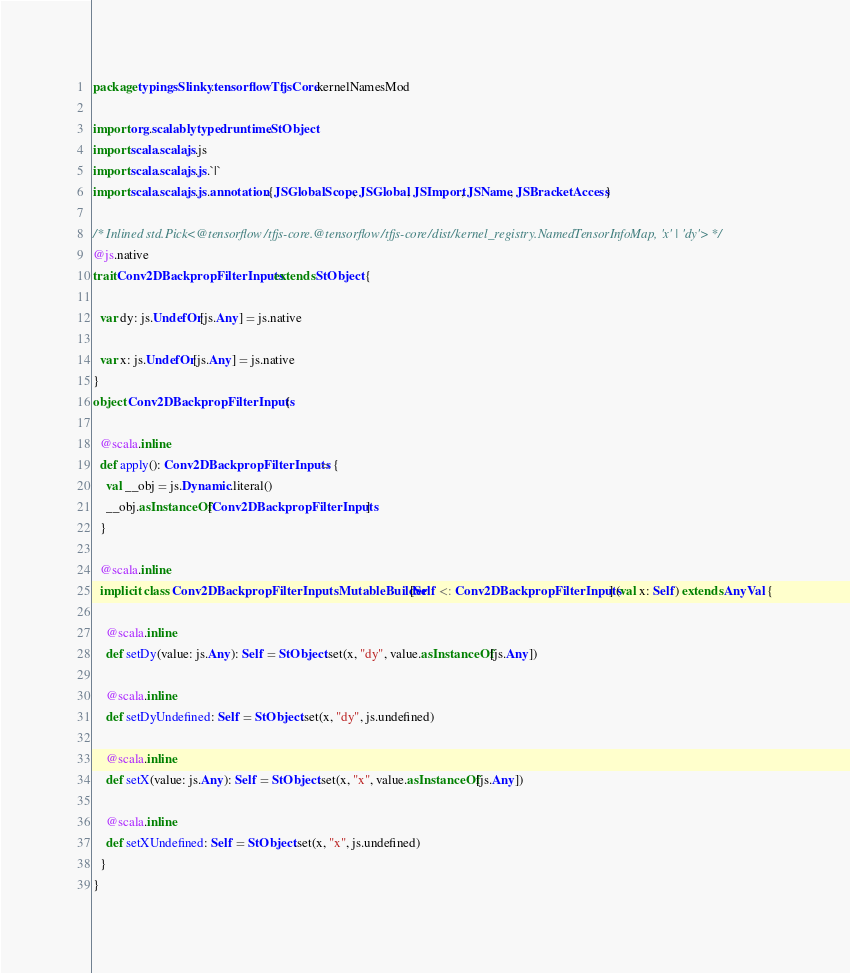<code> <loc_0><loc_0><loc_500><loc_500><_Scala_>package typingsSlinky.tensorflowTfjsCore.kernelNamesMod

import org.scalablytyped.runtime.StObject
import scala.scalajs.js
import scala.scalajs.js.`|`
import scala.scalajs.js.annotation.{JSGlobalScope, JSGlobal, JSImport, JSName, JSBracketAccess}

/* Inlined std.Pick<@tensorflow/tfjs-core.@tensorflow/tfjs-core/dist/kernel_registry.NamedTensorInfoMap, 'x' | 'dy'> */
@js.native
trait Conv2DBackpropFilterInputs extends StObject {
  
  var dy: js.UndefOr[js.Any] = js.native
  
  var x: js.UndefOr[js.Any] = js.native
}
object Conv2DBackpropFilterInputs {
  
  @scala.inline
  def apply(): Conv2DBackpropFilterInputs = {
    val __obj = js.Dynamic.literal()
    __obj.asInstanceOf[Conv2DBackpropFilterInputs]
  }
  
  @scala.inline
  implicit class Conv2DBackpropFilterInputsMutableBuilder[Self <: Conv2DBackpropFilterInputs] (val x: Self) extends AnyVal {
    
    @scala.inline
    def setDy(value: js.Any): Self = StObject.set(x, "dy", value.asInstanceOf[js.Any])
    
    @scala.inline
    def setDyUndefined: Self = StObject.set(x, "dy", js.undefined)
    
    @scala.inline
    def setX(value: js.Any): Self = StObject.set(x, "x", value.asInstanceOf[js.Any])
    
    @scala.inline
    def setXUndefined: Self = StObject.set(x, "x", js.undefined)
  }
}
</code> 